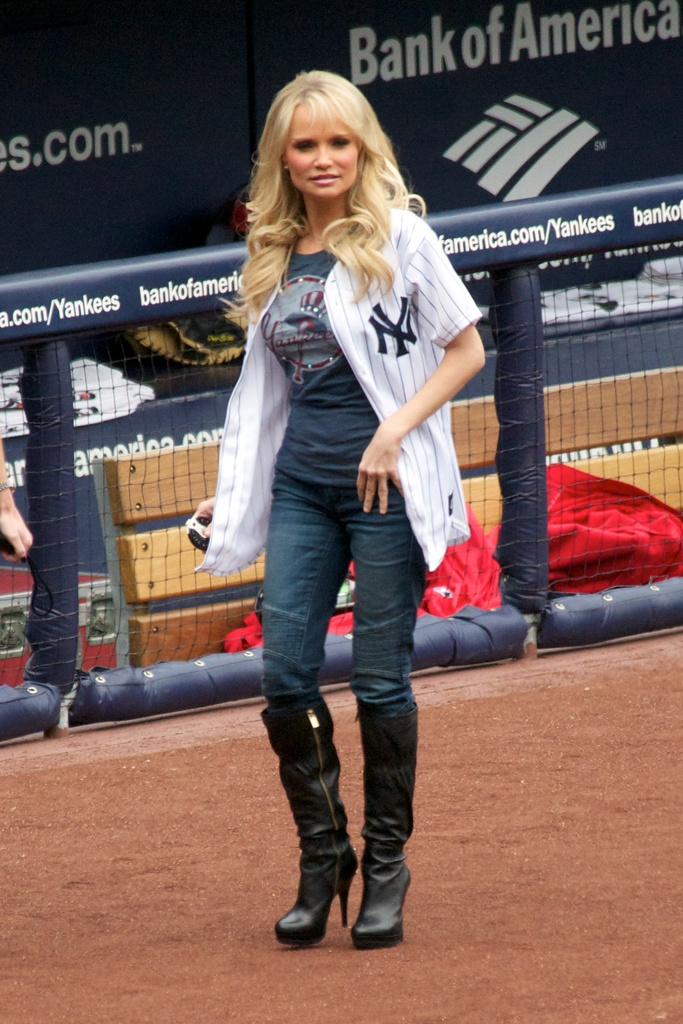What event might be taking place in this image where the woman is dressed in Yankees attire? The woman might be participating in a promotional event or a ceremonial first pitch at a New York Yankees baseball game, indicated by her Yankees jersey and the sports stadium setting. 